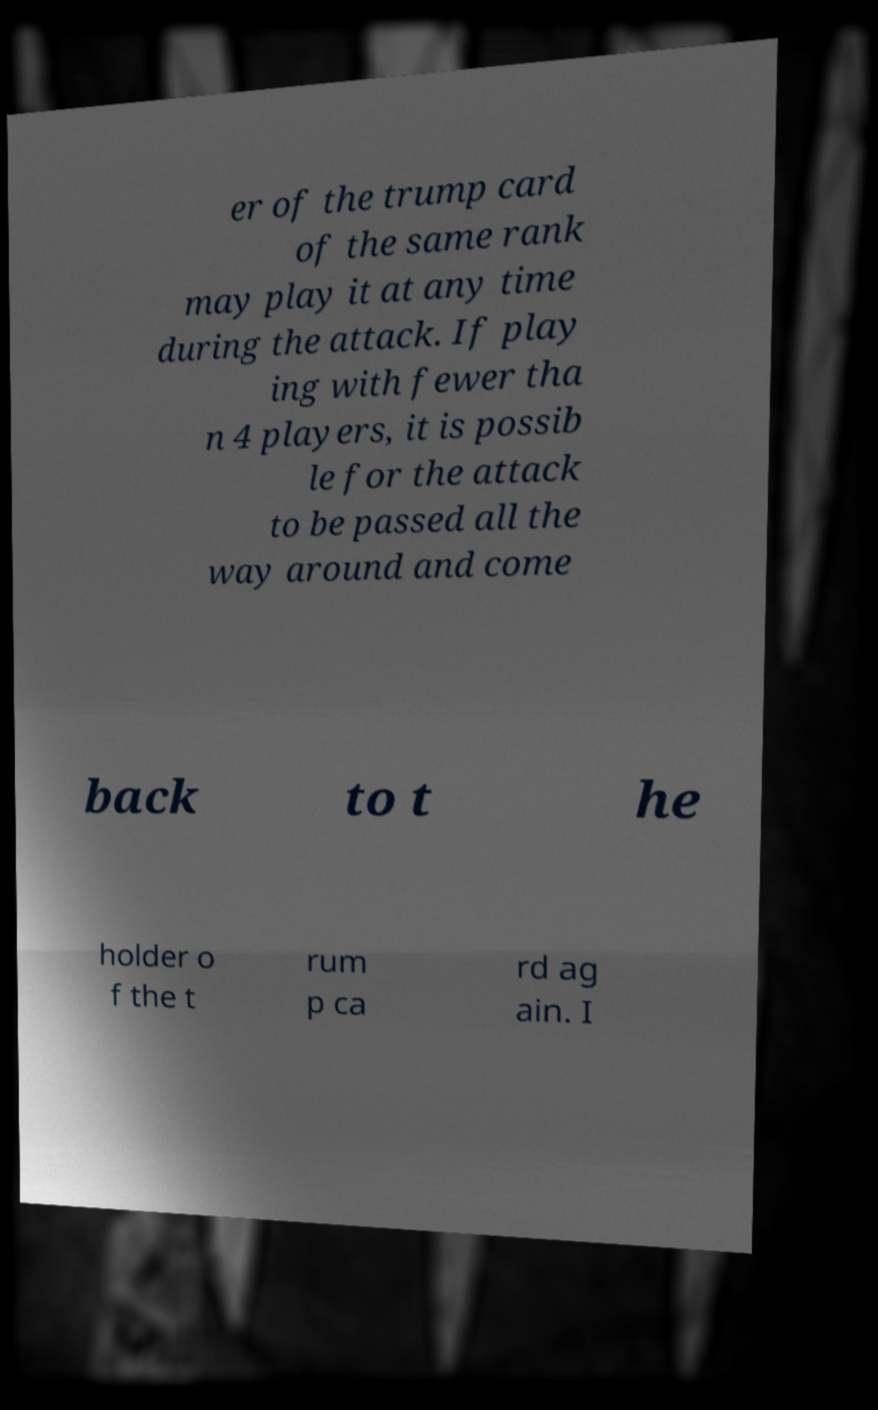Can you accurately transcribe the text from the provided image for me? er of the trump card of the same rank may play it at any time during the attack. If play ing with fewer tha n 4 players, it is possib le for the attack to be passed all the way around and come back to t he holder o f the t rum p ca rd ag ain. I 